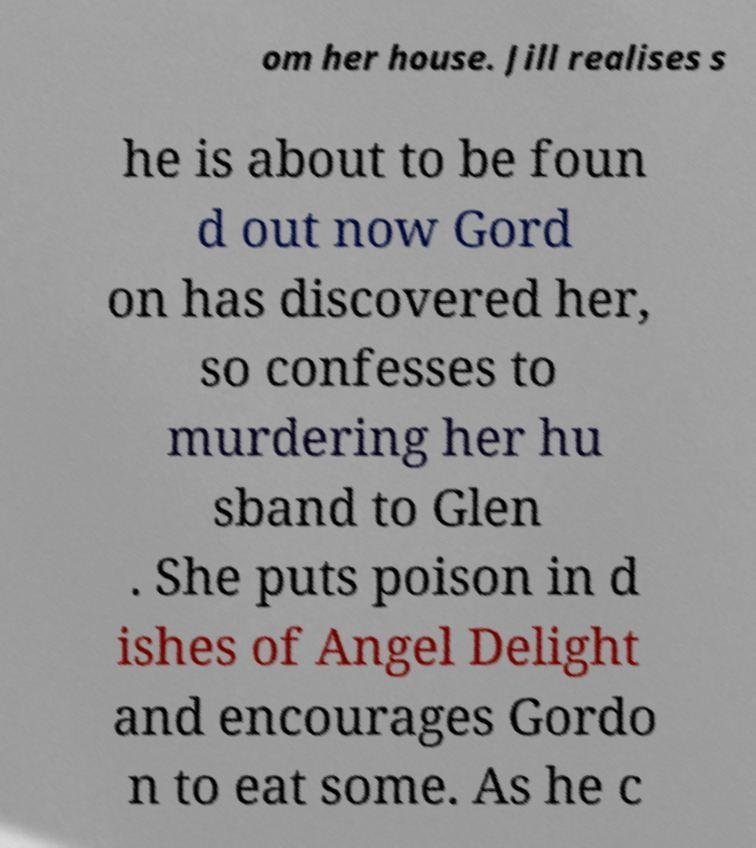Please identify and transcribe the text found in this image. om her house. Jill realises s he is about to be foun d out now Gord on has discovered her, so confesses to murdering her hu sband to Glen . She puts poison in d ishes of Angel Delight and encourages Gordo n to eat some. As he c 